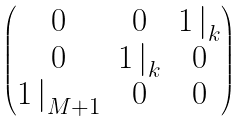<formula> <loc_0><loc_0><loc_500><loc_500>\begin{pmatrix} 0 & 0 & { 1 \, | } _ { k } \\ 0 & { 1 \, | } _ { k } & 0 \\ { 1 \, | } _ { M + 1 } & 0 & 0 \end{pmatrix}</formula> 